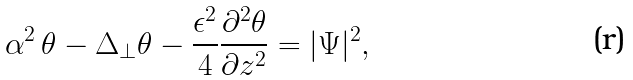Convert formula to latex. <formula><loc_0><loc_0><loc_500><loc_500>\alpha ^ { 2 } \, \theta - \Delta _ { \perp } \theta - \frac { \epsilon ^ { 2 } } { 4 } \frac { \partial ^ { 2 } \theta } { \partial z ^ { 2 } } = | \Psi | ^ { 2 } ,</formula> 